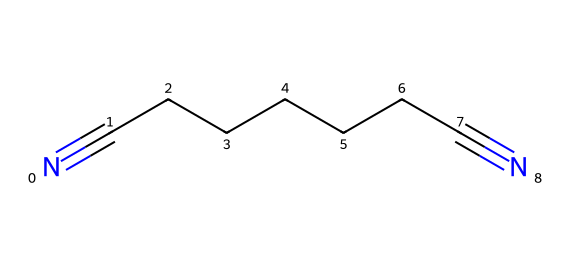What is the molecular formula of this compound? The SMILES representation indicates the chemical consists of 7 carbon atoms (C) and 2 nitrogen atoms (N) with no hydrogen atoms explicitly shown; thus, the molecular formula is C7H10N2.
Answer: C7H10N2 How many triple bonds are present in this molecule? In the SMILES notation, the presence of "#" indicates triple bonds; there are two segments (N#C and C#N) showing two triple bonds in the molecule.
Answer: 2 What type of functional groups are present? The structure shows nitrile groups (–C≡N), which are characterized by the presence of triple bonds between carbon and nitrogen, indicating that nitriles are the primary functional groups present in the compound.
Answer: nitrile Is this compound likely to be soluble in water? Given the structure of the compound, nitriles are typically less polar due to the presence of long carbon chains, thus they generally have low solubility in water.
Answer: low What is the impact of adiponitrile on atmospheric composition? Adiponitrile can contribute to atmospheric pollution by participating in reactions that lead to the formation of secondary pollutants, affecting air quality and contributing to climate change.
Answer: pollution contributor What is the significance of the carbon chain length in adiponitrile concerning its volatility? The long carbon chain increases hydrophobicity and reduces volatility; thus, adiponitrile has lower volatility compared to shorter-chain nitriles and is likely to persist longer in the environment.
Answer: lower volatility What are the potential toxic effects of adiponitrile exposure? Adiponitrile can cause neurotoxic effects and irritation to the skin and respiratory system, implying that it poses significant health risks upon exposure.
Answer: neurotoxic effects 